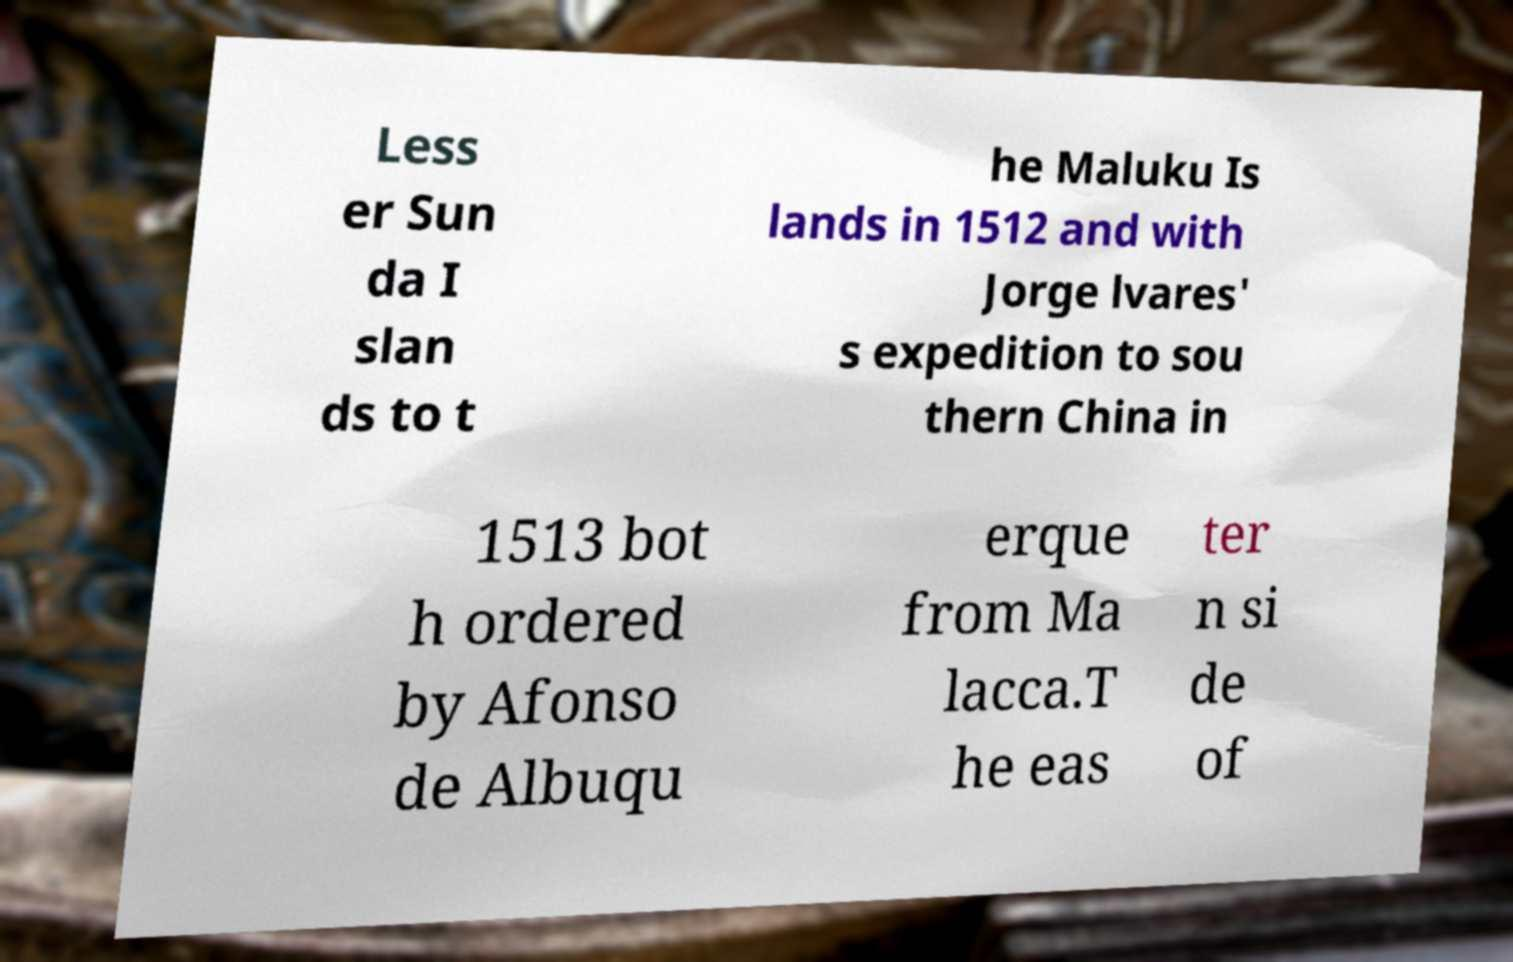I need the written content from this picture converted into text. Can you do that? Less er Sun da I slan ds to t he Maluku Is lands in 1512 and with Jorge lvares' s expedition to sou thern China in 1513 bot h ordered by Afonso de Albuqu erque from Ma lacca.T he eas ter n si de of 